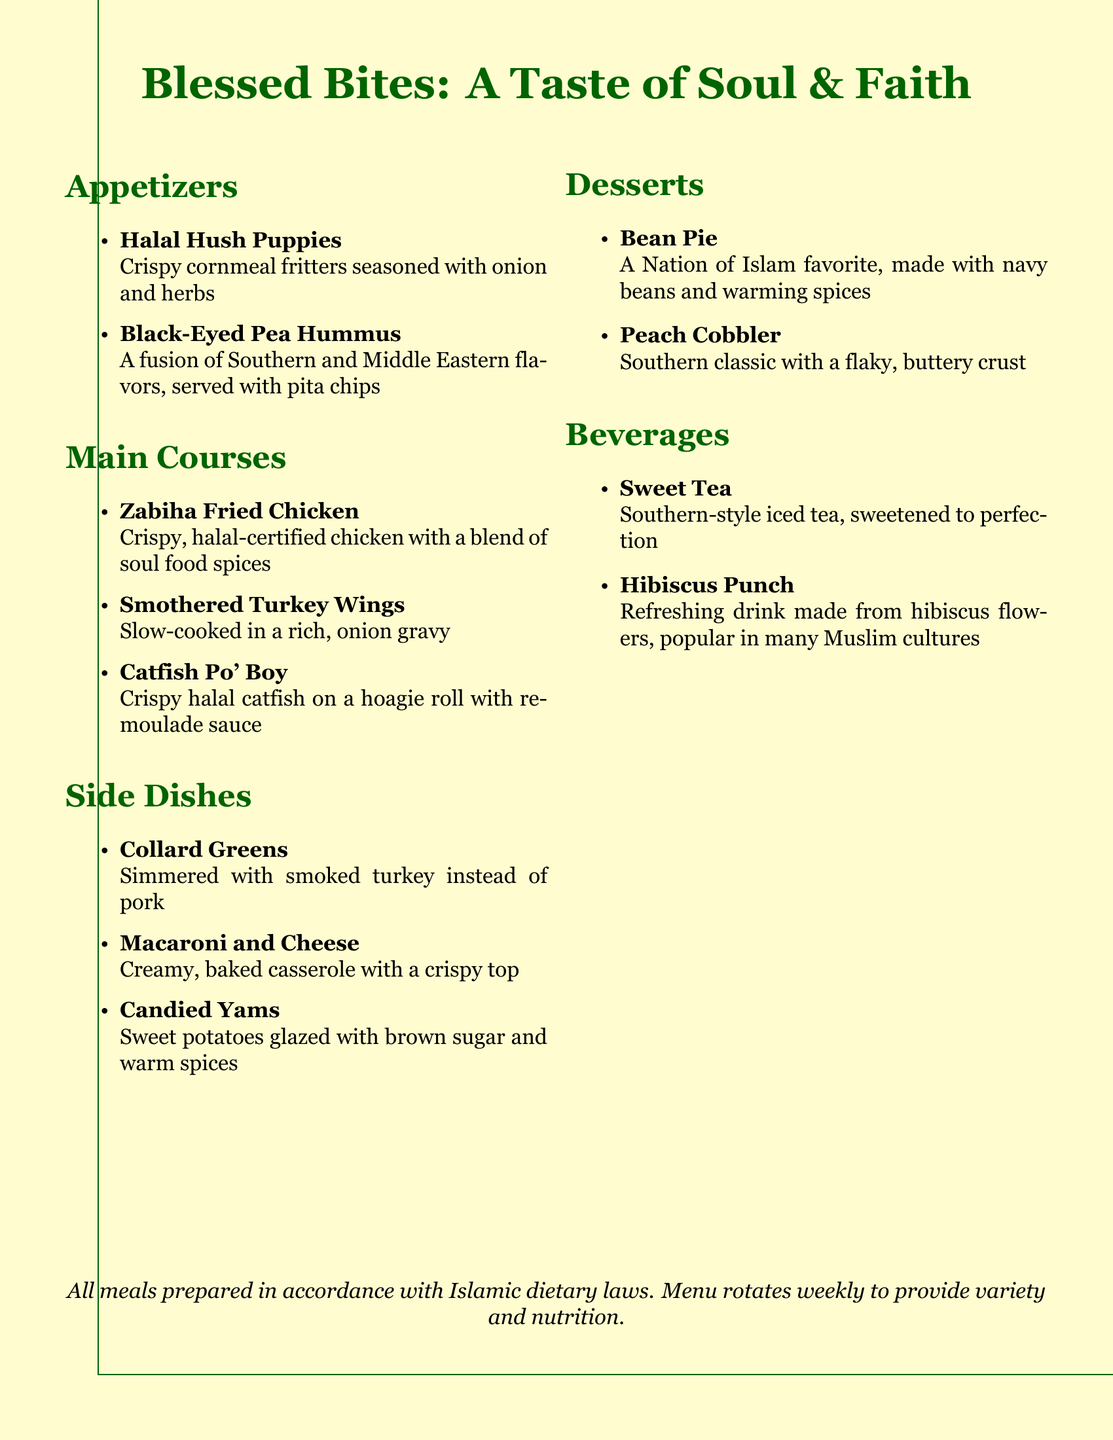What is the title of the menu? The title of the menu is prominently displayed at the top, indicating the theme of the offerings.
Answer: Blessed Bites: A Taste of Soul & Faith How many appetizers are listed? The menu lists two appetizers under the respective section, which can be counted directly.
Answer: 2 What is the main ingredient of the Halal Hush Puppies? The main ingredient is found in the description of the dish, highlighting its primary component.
Answer: Cornmeal Which dish uses turkey in its preparation? The dish is specifically mentioned in the side dishes section as being made with smoked turkey.
Answer: Collard Greens What type of drink is Hibiscus Punch? The menu provides a brief description of the drinks, indicating its nature and cultural significance.
Answer: Refreshing What common soul food dessert is featured? The dessert is a well-known Southern classic clearly stated in the dessert section of the menu.
Answer: Peach Cobbler Which main course is described as slow-cooked? The description notes the cooking method used for one specific main course, highlighting its preparation style.
Answer: Smothered Turkey Wings What is the flavor fusion in the Black-Eyed Pea Hummus? The flavors are described within the context of the dish, combining two cultural influences.
Answer: Southern and Middle Eastern 